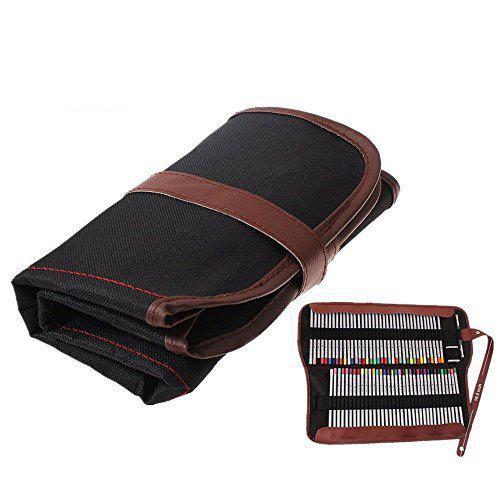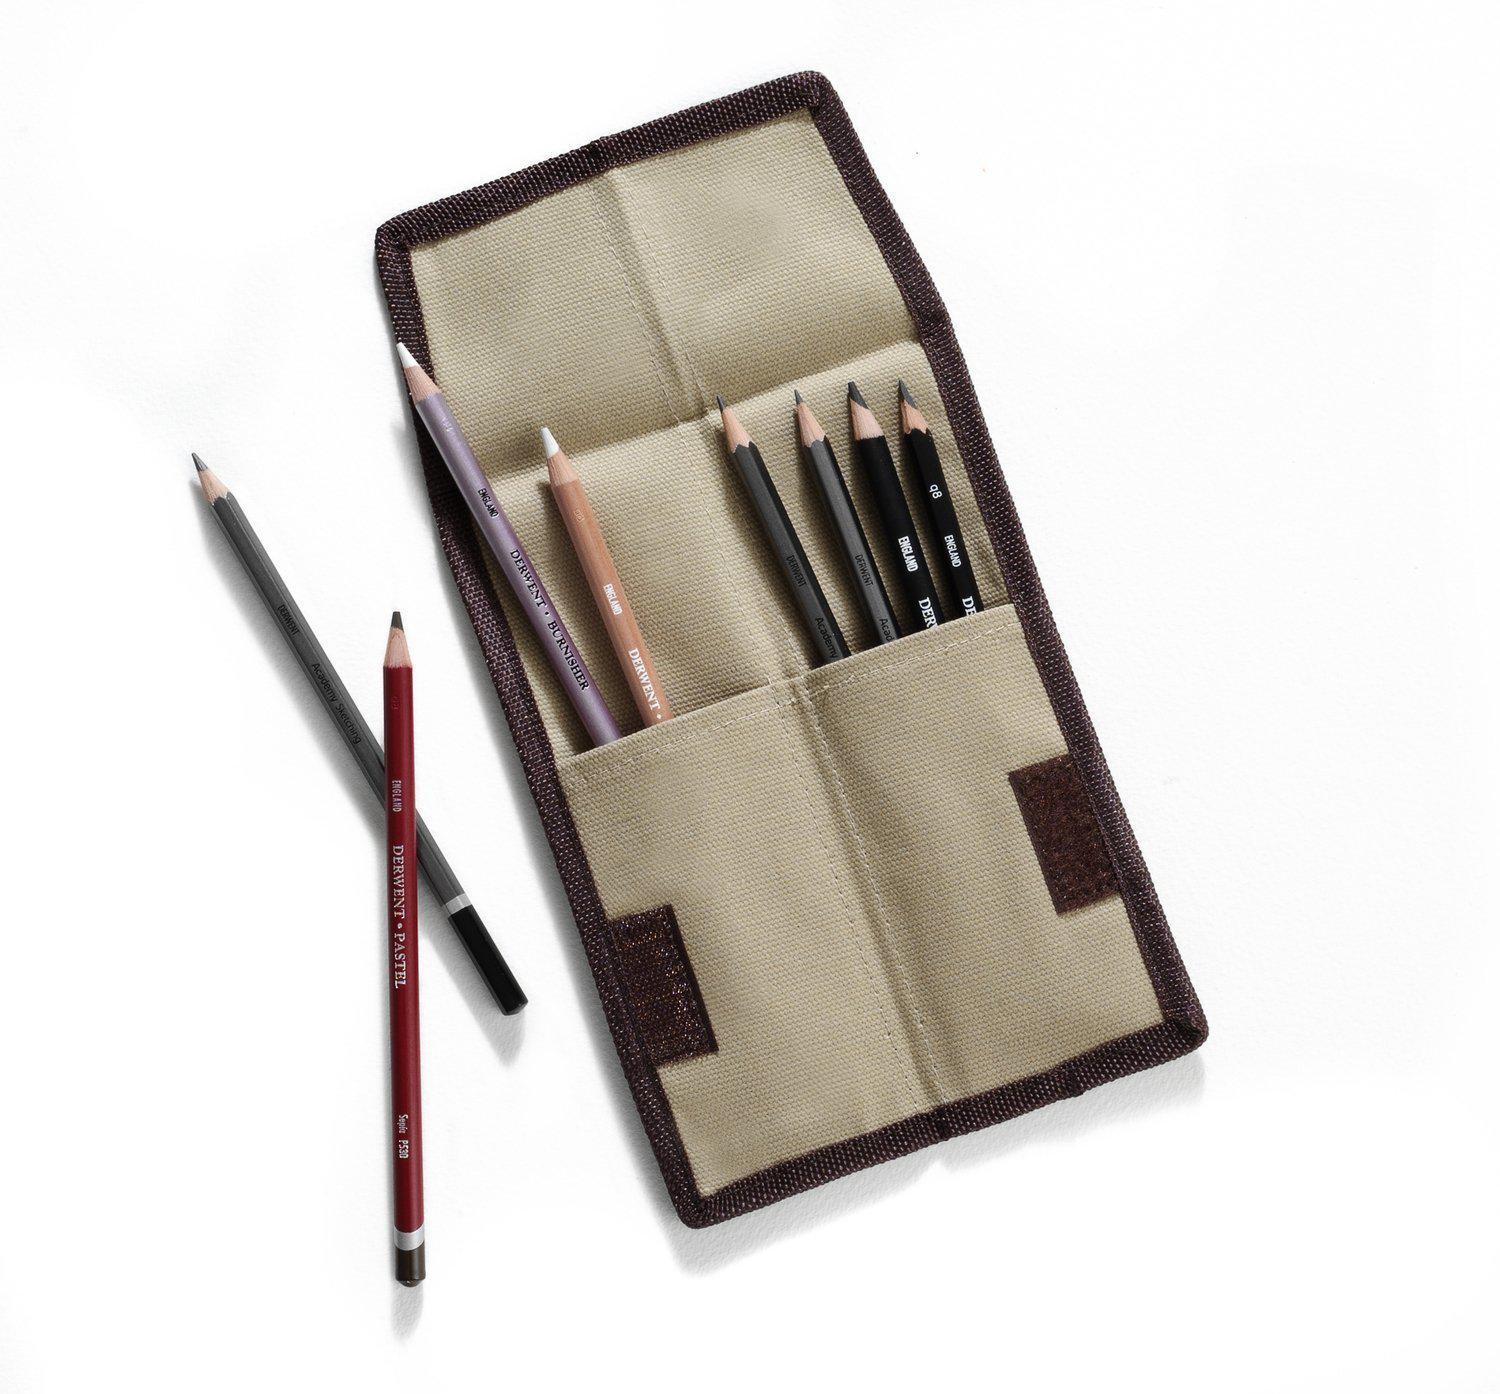The first image is the image on the left, the second image is the image on the right. Examine the images to the left and right. Is the description "One image shows a fold-out pencil case forming a triangle shape and filled with colored-lead pencils." accurate? Answer yes or no. No. The first image is the image on the left, the second image is the image on the right. For the images displayed, is the sentence "Some of the pencils are completely out of the case in one of the images." factually correct? Answer yes or no. Yes. 